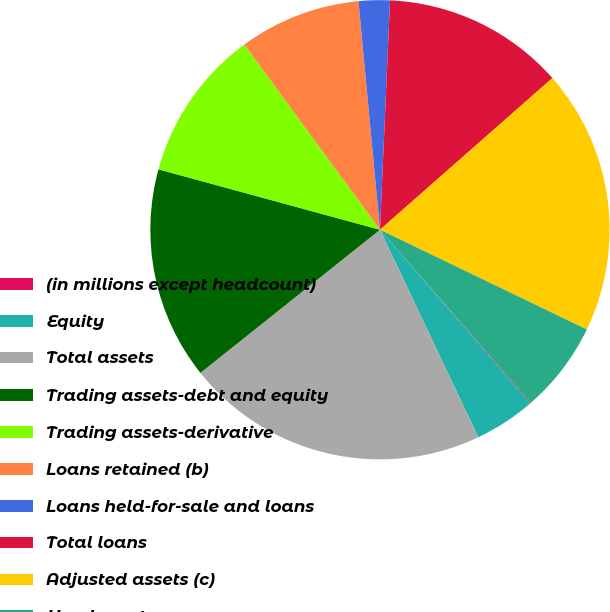Convert chart. <chart><loc_0><loc_0><loc_500><loc_500><pie_chart><fcel>(in millions except headcount)<fcel>Equity<fcel>Total assets<fcel>Trading assets-debt and equity<fcel>Trading assets-derivative<fcel>Loans retained (b)<fcel>Loans held-for-sale and loans<fcel>Total loans<fcel>Adjusted assets (c)<fcel>Headcount<nl><fcel>0.06%<fcel>4.31%<fcel>21.33%<fcel>14.95%<fcel>10.7%<fcel>8.57%<fcel>2.19%<fcel>12.82%<fcel>18.63%<fcel>6.44%<nl></chart> 